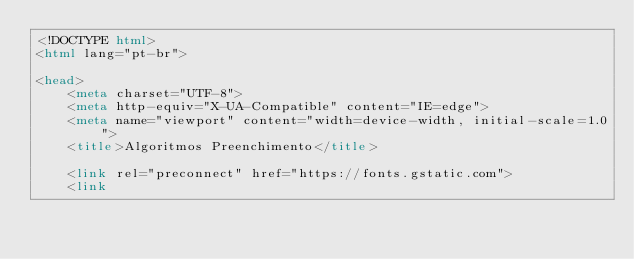Convert code to text. <code><loc_0><loc_0><loc_500><loc_500><_HTML_><!DOCTYPE html>
<html lang="pt-br">

<head>
    <meta charset="UTF-8">
    <meta http-equiv="X-UA-Compatible" content="IE=edge">
    <meta name="viewport" content="width=device-width, initial-scale=1.0">
    <title>Algoritmos Preenchimento</title>

    <link rel="preconnect" href="https://fonts.gstatic.com">
    <link</code> 